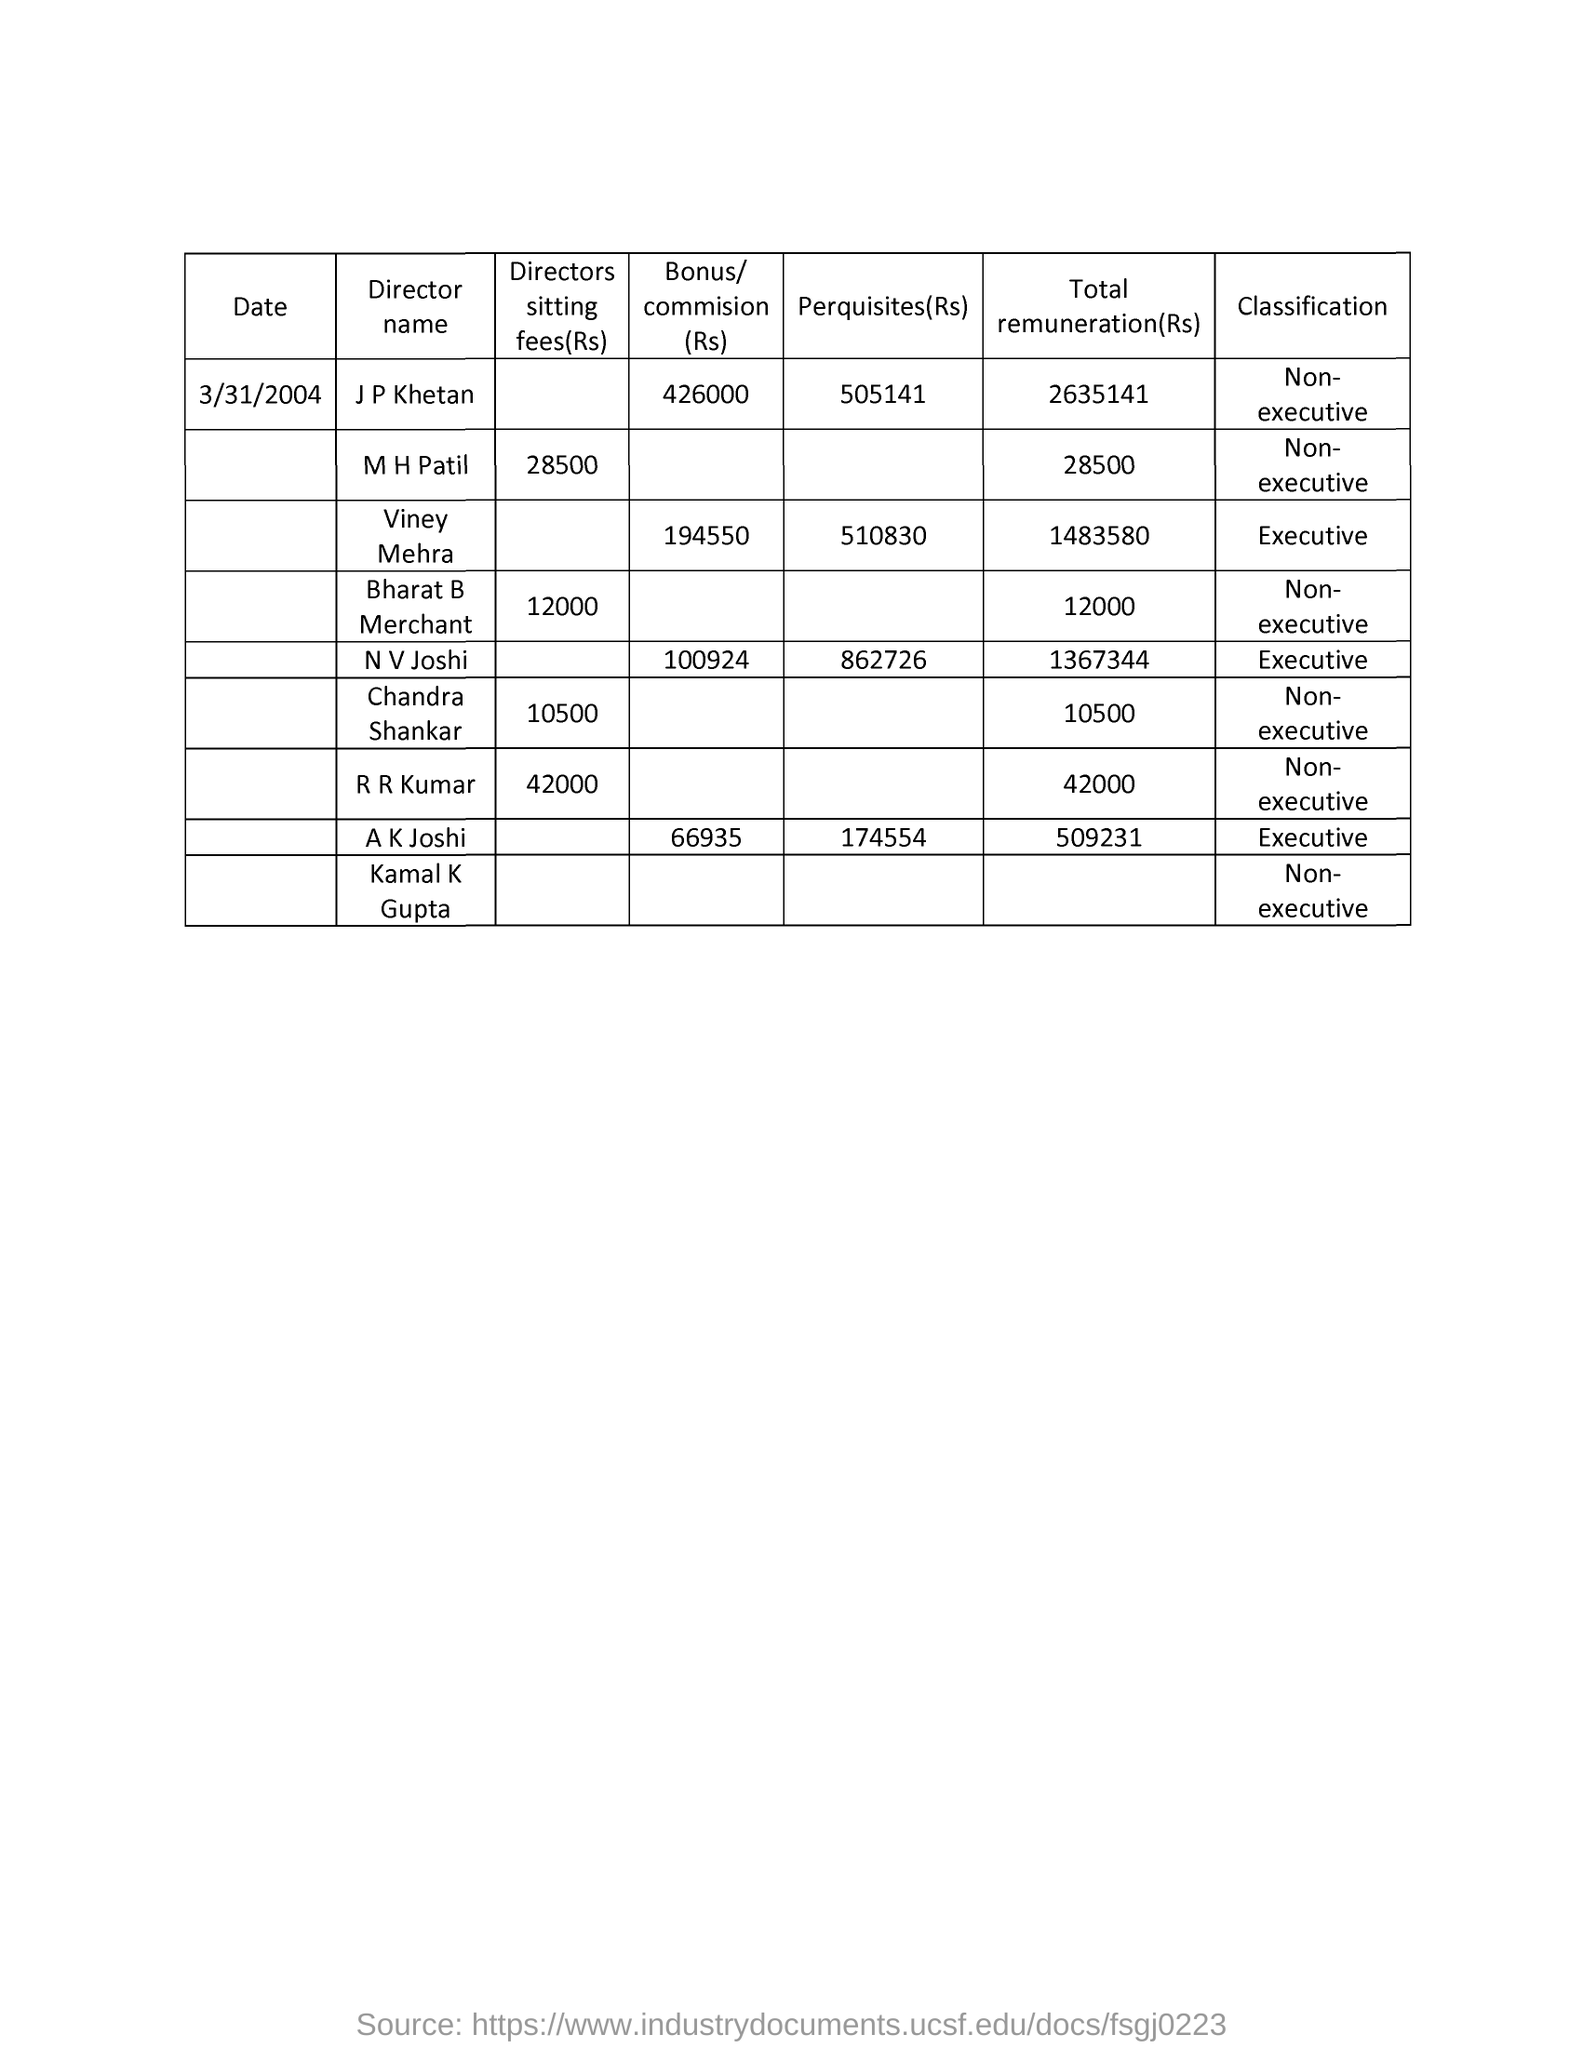What is the date mentioned in the document?
Offer a very short reply. 3/31/2004. What is the name of the director whose perquisites(rs) is 505141?
Your answer should be very brief. J P Khetan. What is the director sitting fee of r r kumar?
Your answer should be very brief. 42000. What is the total remuneration of bharat b merchant?
Ensure brevity in your answer.  12000. 